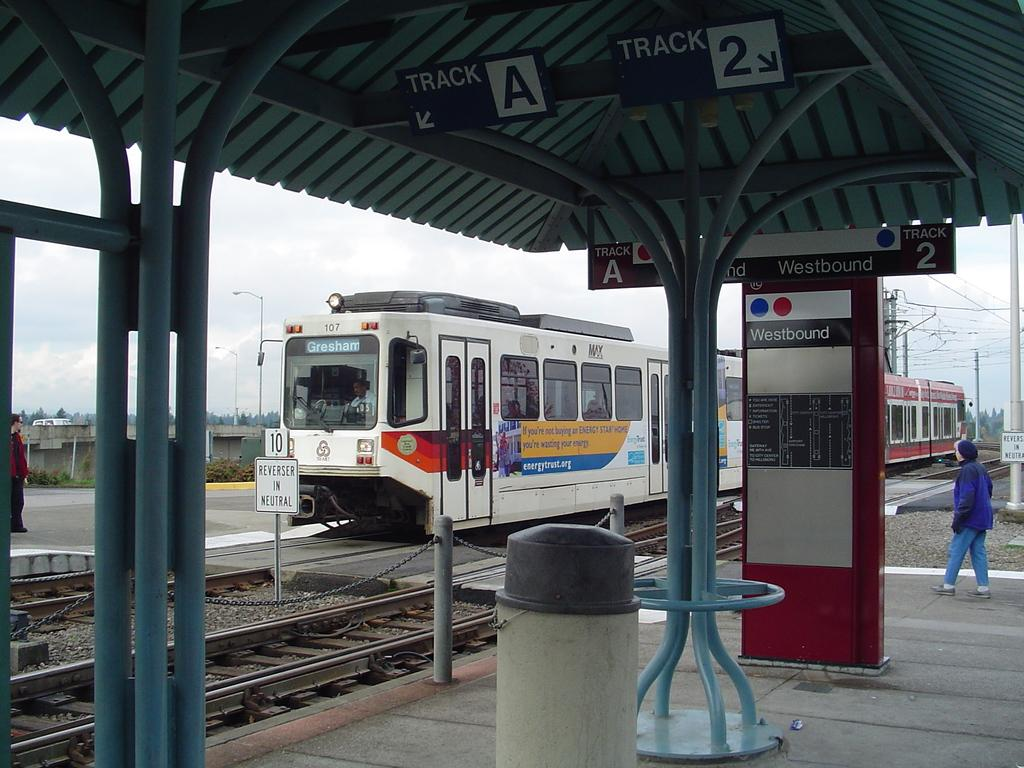<image>
Provide a brief description of the given image. A train to Gresham is stopped on tracks as a woman approaches. 